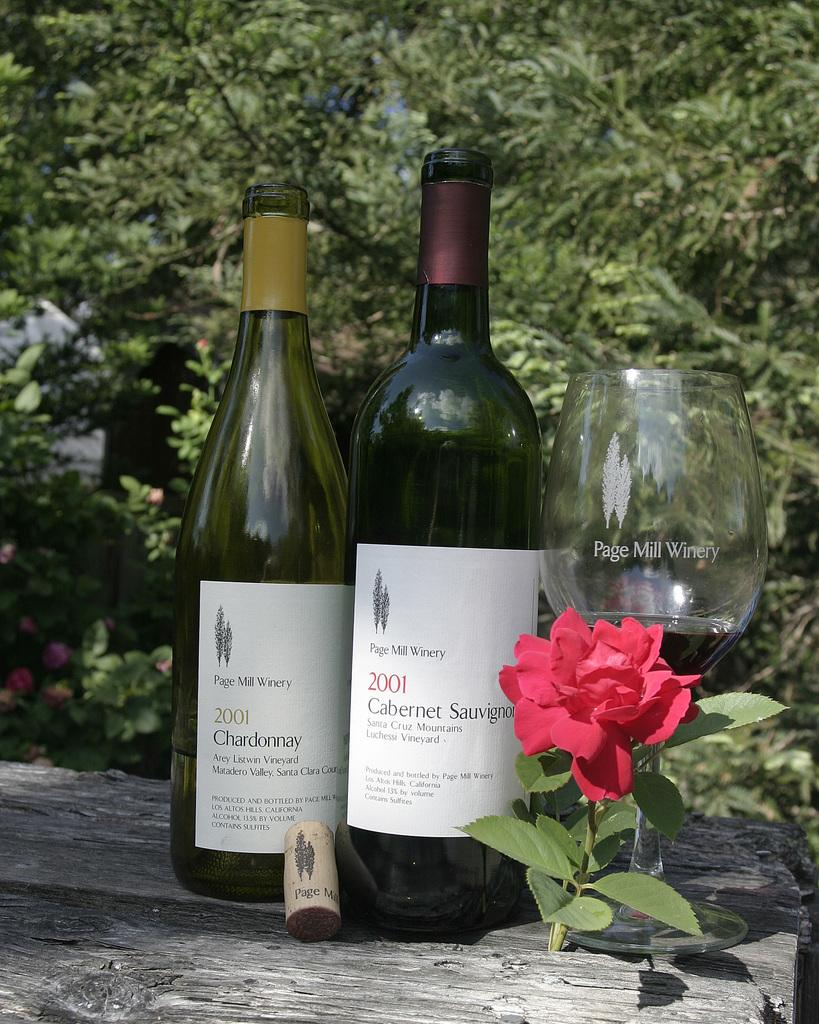<image>
Describe the image concisely. Two bottle of wine from Page Mill Winery sit outdoors. 